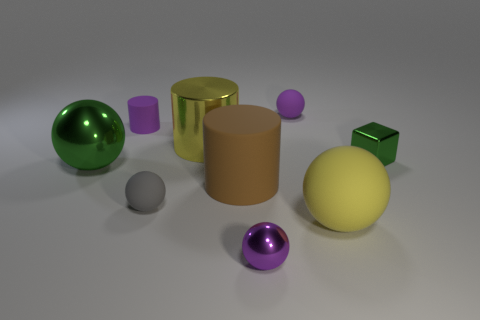Subtract 2 spheres. How many spheres are left? 3 Subtract all tiny purple metal balls. How many balls are left? 4 Subtract all green spheres. How many spheres are left? 4 Subtract all brown balls. Subtract all red cylinders. How many balls are left? 5 Subtract all cubes. How many objects are left? 8 Subtract all small yellow matte things. Subtract all blocks. How many objects are left? 8 Add 1 small cylinders. How many small cylinders are left? 2 Add 7 small gray things. How many small gray things exist? 8 Subtract 0 red blocks. How many objects are left? 9 